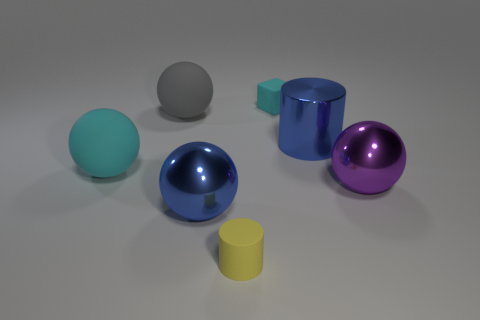Is the number of small objects that are behind the gray sphere greater than the number of big purple cubes?
Provide a succinct answer. Yes. Is there a gray sphere that has the same material as the large cylinder?
Provide a succinct answer. No. Is the purple ball that is behind the yellow rubber cylinder made of the same material as the big blue object that is to the left of the tiny yellow cylinder?
Make the answer very short. Yes. Are there the same number of small yellow things that are in front of the small yellow matte cylinder and large cylinders that are on the right side of the cyan matte cube?
Your answer should be very brief. No. The cylinder that is the same size as the cyan rubber ball is what color?
Your answer should be compact. Blue. Are there any metal balls of the same color as the large cylinder?
Your response must be concise. Yes. How many objects are big things in front of the big purple shiny ball or blue blocks?
Provide a short and direct response. 1. How many other things are there of the same size as the gray rubber thing?
Your answer should be very brief. 4. What is the material of the small thing that is in front of the rubber sphere that is behind the large blue metallic thing behind the big cyan thing?
Offer a terse response. Rubber. What number of balls are shiny things or cyan objects?
Offer a very short reply. 3. 